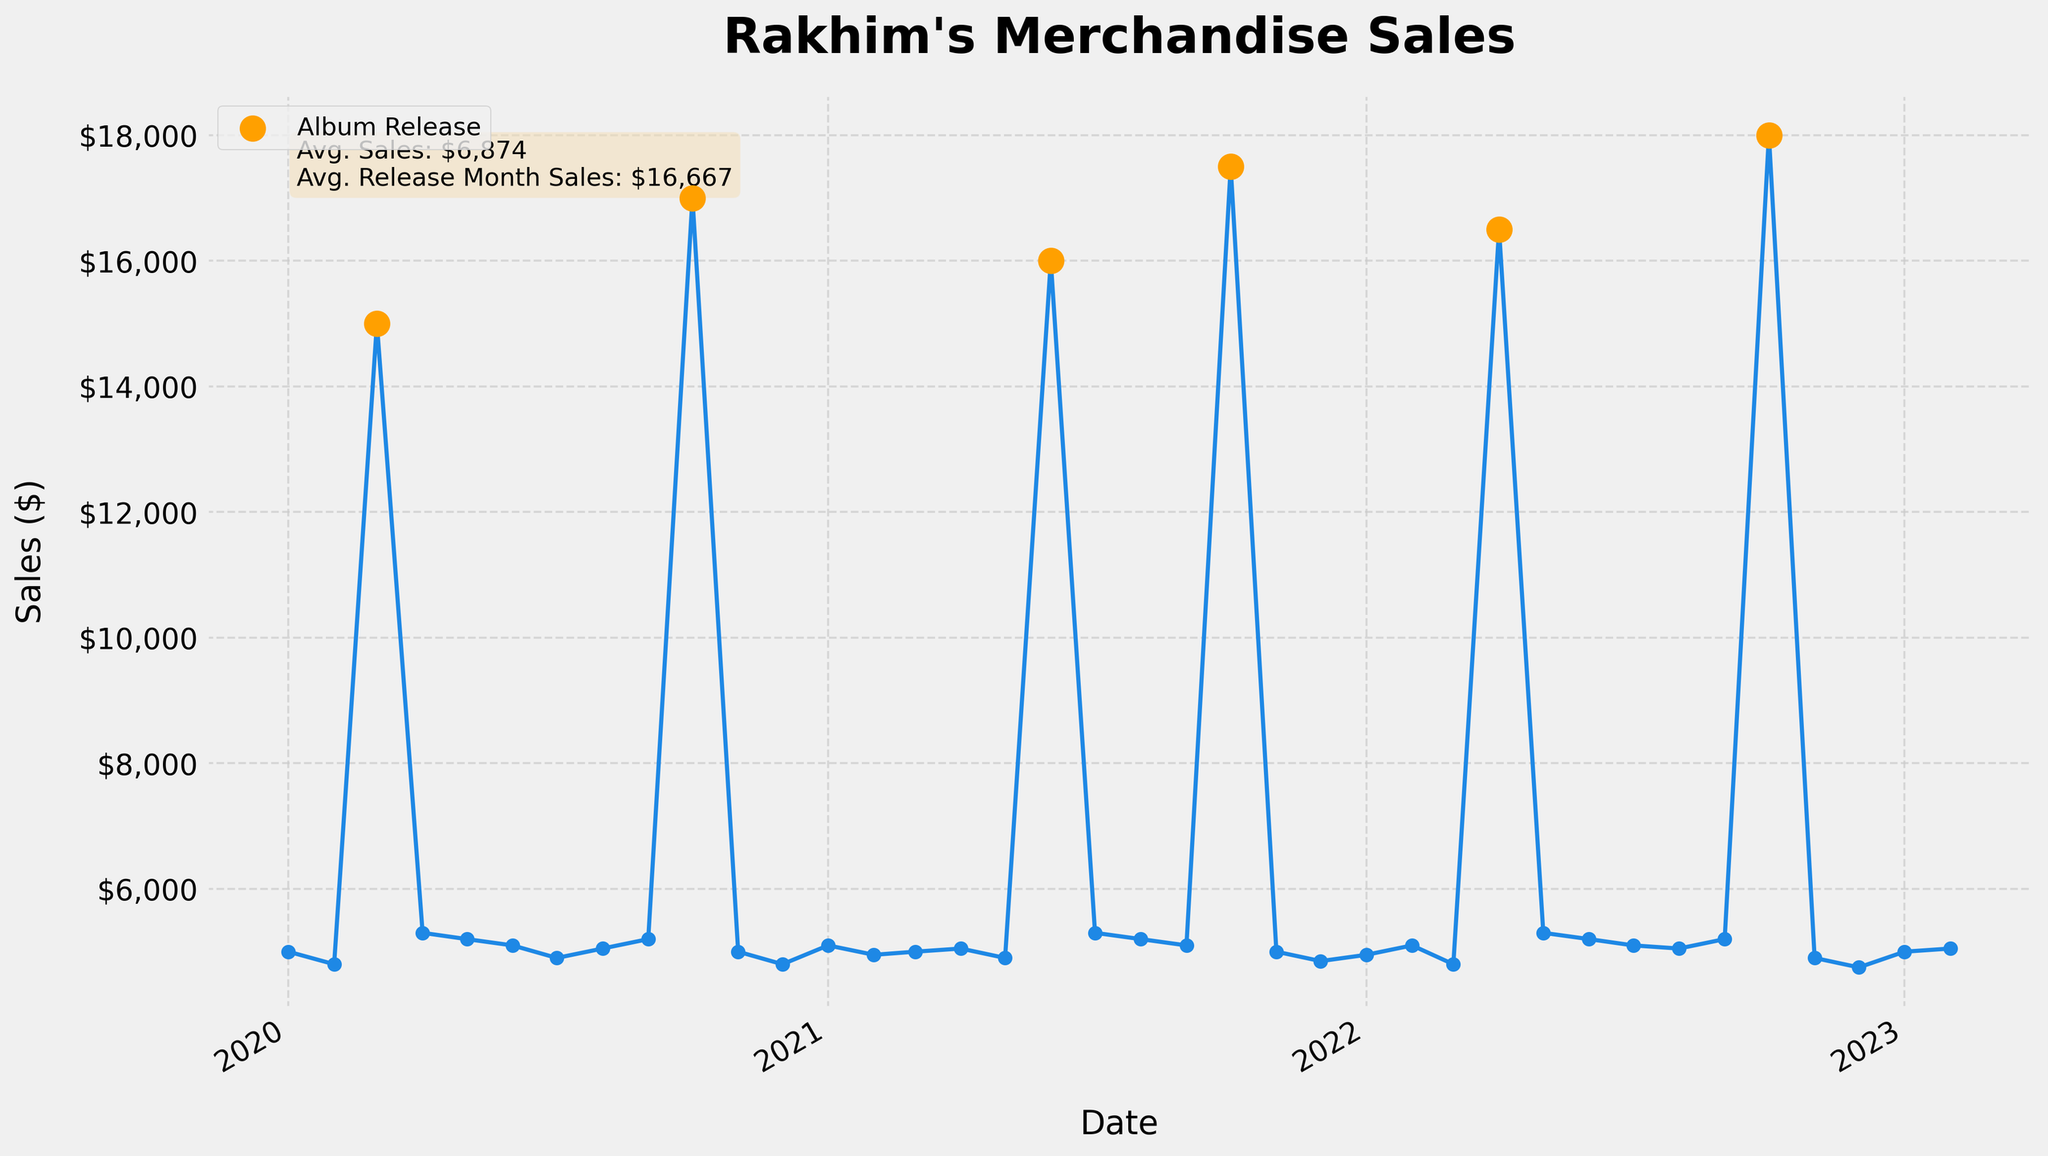What is the title of the plot? The title of the plot is typically found at the top of the figure. It is used to give a brief description of what the plot represents.
Answer: Rakhim's Merchandise Sales What colors are used to differentiate the album release months from other months? The plot uses different colors for better visual distinction. Album release months are marked with orange circles, whereas the rest of the data points are shown in blue.
Answer: Orange and Blue How many album releases occurred over the past three years? By counting the number of orange scatter points on the plot representing album release months, we can determine the total number of album releases.
Answer: 6 What is the range of merchandise sales value? The lowest and highest points on the y-axis give a hint about the merchandise sales range. By looking at the plot, we can see the spread of data points. The lowest value is around $4,750, and the highest reaches $18,000, thus the range.
Answer: $4,750 to $18,000 In which month and year did the maximum merchandise sales occur, and what was the value? By identifying the highest data point on the plot, and correlating it to the month and year on the x-axis, we find that the maximum sales value happened in October 2022 and was $18,000.
Answer: October 2022, $18,000 What is the average merchandise sales during the album release months? The box on the plot mentions this information. The average sales during release months can be found noted in a text box within the plot area.
Answer: $16,667 How do merchandise sales compare between months with and without album releases? Comparing the heights of the orange points (album release months) and blue points (other months) allows for a general observation that sales are significantly higher during album release months on average.
Answer: Higher during album release months Which month and year saw the lowest merchandise sales, and what was the value? By identifying the lowest data point on the plot and correlating it to the month and year on the x-axis, we find that the lowest sales value happened in December 2022 and was $4,750.
Answer: December 2022, $4,750 What is the trend of merchandise sales over the three years? Observing the plot from the beginning to the end gives a sense of overall trends. Generally, there is a consistent trend with sharp peaks during album releases and moderate fluctuations otherwise.
Answer: Consistent with peaks during releases 